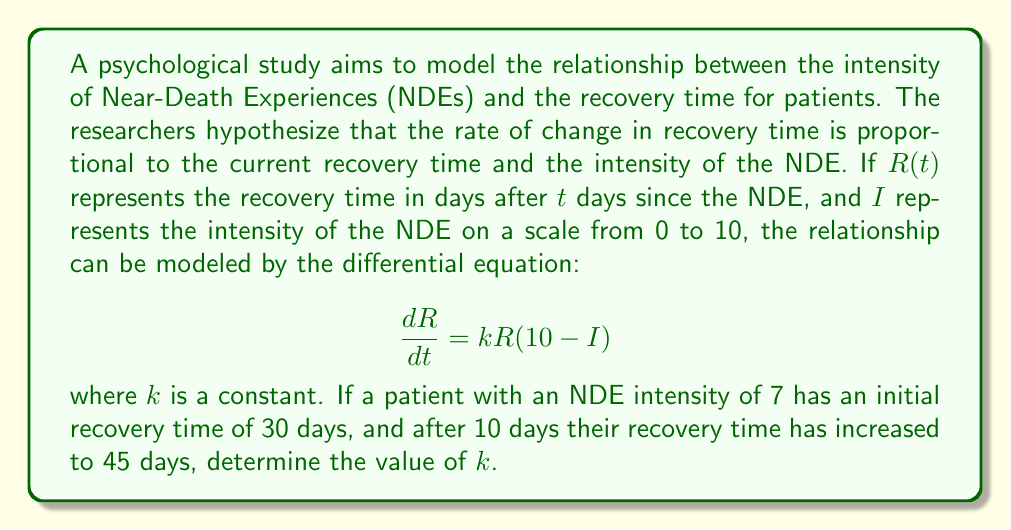What is the answer to this math problem? To solve this problem, we need to follow these steps:

1) First, we need to solve the differential equation. This is a separable equation:

   $$\frac{dR}{R} = k(10-I)dt$$

2) Integrating both sides:

   $$\int \frac{dR}{R} = \int k(10-I)dt$$
   $$\ln|R| = k(10-I)t + C$$

3) Solving for $R$:

   $$R = Ce^{k(10-I)t}$$

   where $C$ is a constant of integration.

4) Now, we can use the initial condition. When $t=0$, $R=30$:

   $$30 = Ce^{k(10-7)(0)} = C$$

5) So our solution is:

   $$R = 30e^{3kt}$$

6) We can use the second condition to find $k$. When $t=10$, $R=45$:

   $$45 = 30e^{3k(10)}$$

7) Solving for $k$:

   $$\frac{45}{30} = e^{30k}$$
   $$\ln(\frac{3}{2}) = 30k$$
   $$k = \frac{\ln(\frac{3}{2})}{30}$$

8) Calculate the final value:

   $$k = \frac{\ln(1.5)}{30} \approx 0.0135$$
Answer: $k \approx 0.0135$ days$^{-1}$ 